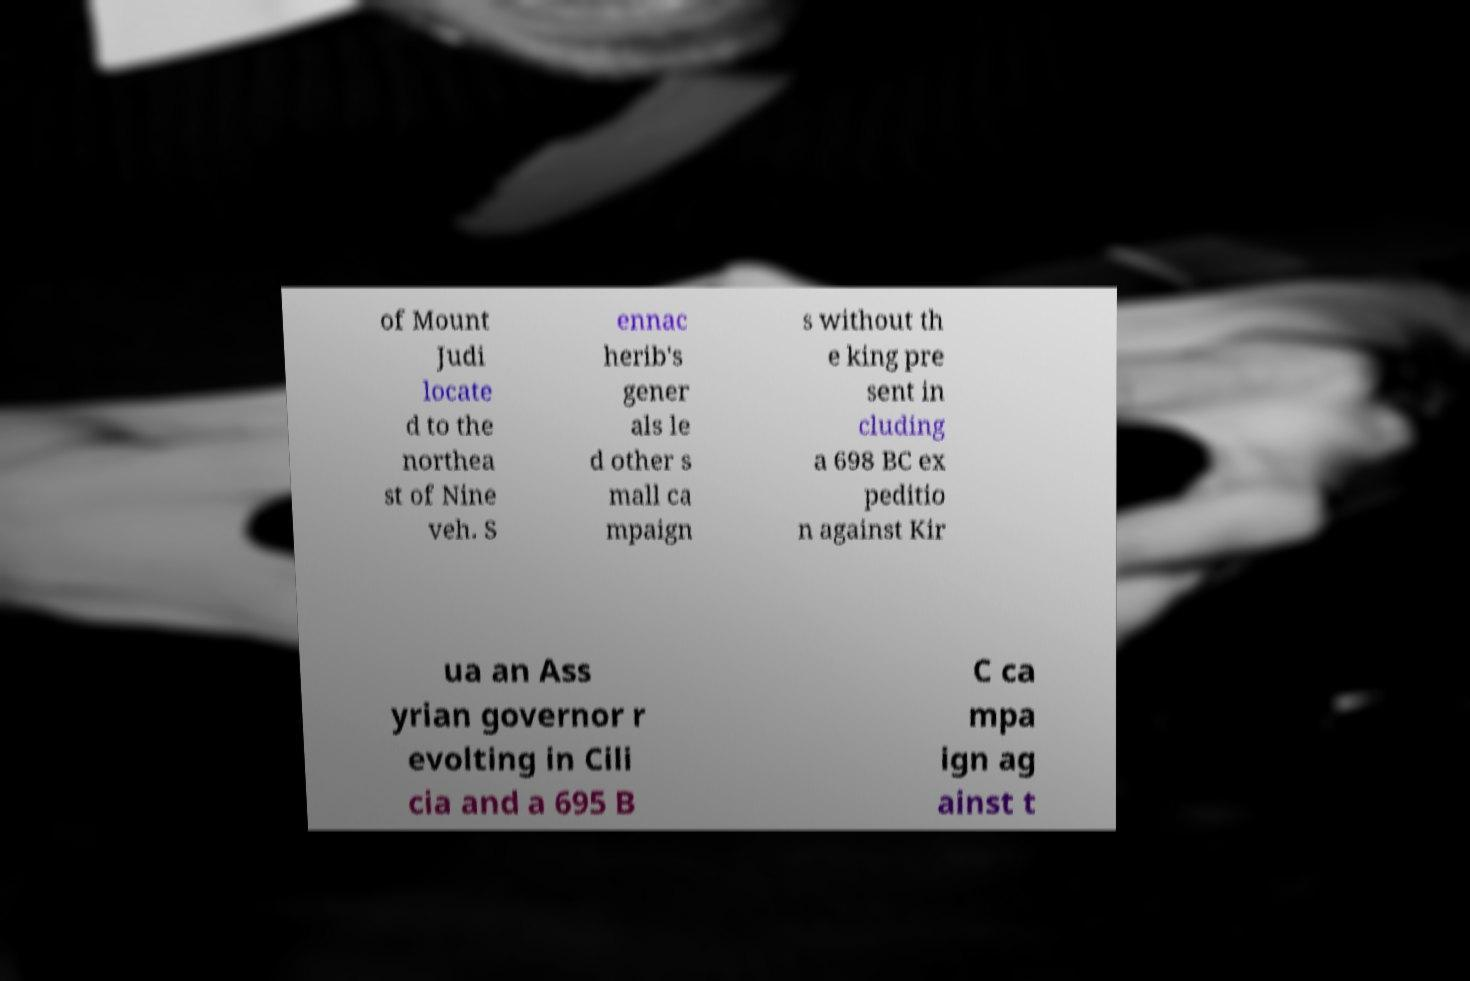What messages or text are displayed in this image? I need them in a readable, typed format. of Mount Judi locate d to the northea st of Nine veh. S ennac herib's gener als le d other s mall ca mpaign s without th e king pre sent in cluding a 698 BC ex peditio n against Kir ua an Ass yrian governor r evolting in Cili cia and a 695 B C ca mpa ign ag ainst t 